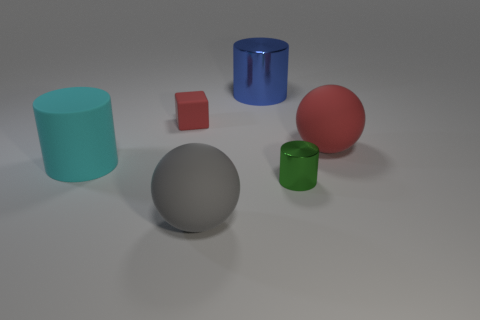Add 1 big blue objects. How many objects exist? 7 Subtract all large matte cylinders. How many cylinders are left? 2 Subtract 1 cylinders. How many cylinders are left? 2 Subtract all blocks. How many objects are left? 5 Add 1 tiny brown shiny blocks. How many tiny brown shiny blocks exist? 1 Subtract 0 yellow blocks. How many objects are left? 6 Subtract all purple cubes. Subtract all green balls. How many cubes are left? 1 Subtract all tiny shiny cylinders. Subtract all yellow metal objects. How many objects are left? 5 Add 3 big matte balls. How many big matte balls are left? 5 